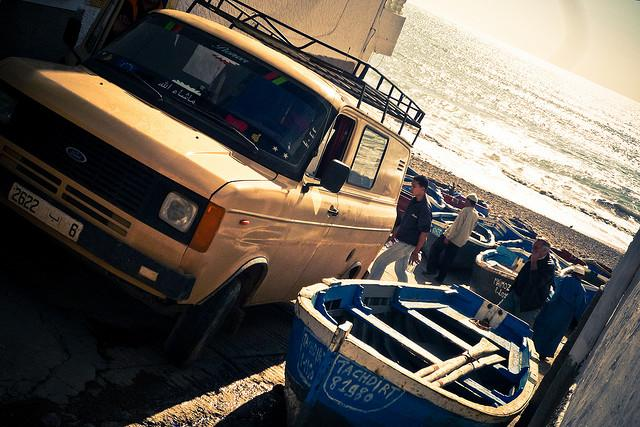What are the first two numbers on the truck?

Choices:
A) 45
B) 96
C) 88
D) 26 26 